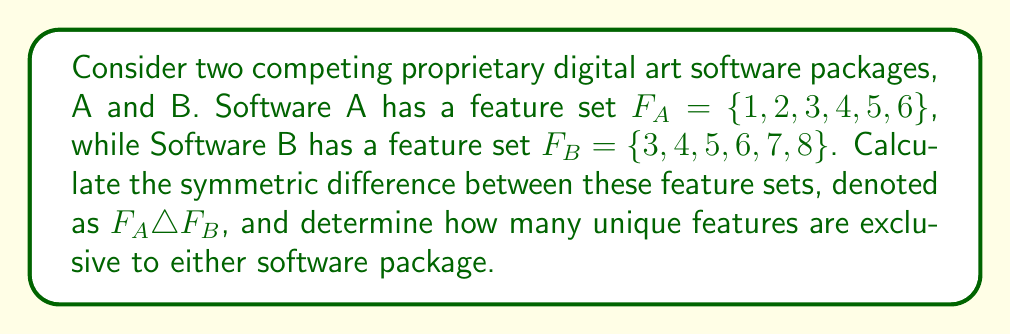Provide a solution to this math problem. To solve this problem, we need to understand the concept of symmetric difference and apply it to the given feature sets.

1. The symmetric difference of two sets A and B, denoted as $A \triangle B$, is defined as the set of elements that are in either A or B, but not in both.

2. Mathematically, this can be expressed as:
   $A \triangle B = (A \setminus B) \cup (B \setminus A)$
   where $\setminus$ represents set difference.

3. For our problem:
   $F_A = \{1, 2, 3, 4, 5, 6\}$
   $F_B = \{3, 4, 5, 6, 7, 8\}$

4. Let's find $F_A \setminus F_B$ (elements in A but not in B):
   $F_A \setminus F_B = \{1, 2\}$

5. Now, let's find $F_B \setminus F_A$ (elements in B but not in A):
   $F_B \setminus F_A = \{7, 8\}$

6. The symmetric difference is the union of these two sets:
   $F_A \triangle F_B = (F_A \setminus F_B) \cup (F_B \setminus F_A) = \{1, 2\} \cup \{7, 8\} = \{1, 2, 7, 8\}$

7. To determine how many unique features are exclusive to either software package, we simply need to count the elements in the symmetric difference.

8. $|F_A \triangle F_B| = |\{1, 2, 7, 8\}| = 4$

Therefore, there are 4 unique features that are exclusive to either Software A or Software B.
Answer: The symmetric difference $F_A \triangle F_B = \{1, 2, 7, 8\}$, and there are 4 unique features exclusive to either software package. 